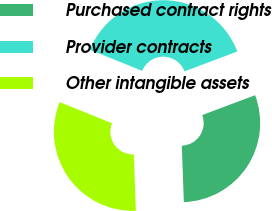Convert chart to OTSL. <chart><loc_0><loc_0><loc_500><loc_500><pie_chart><fcel>Purchased contract rights<fcel>Provider contracts<fcel>Other intangible assets<nl><fcel>30.15%<fcel>38.17%<fcel>31.68%<nl></chart> 